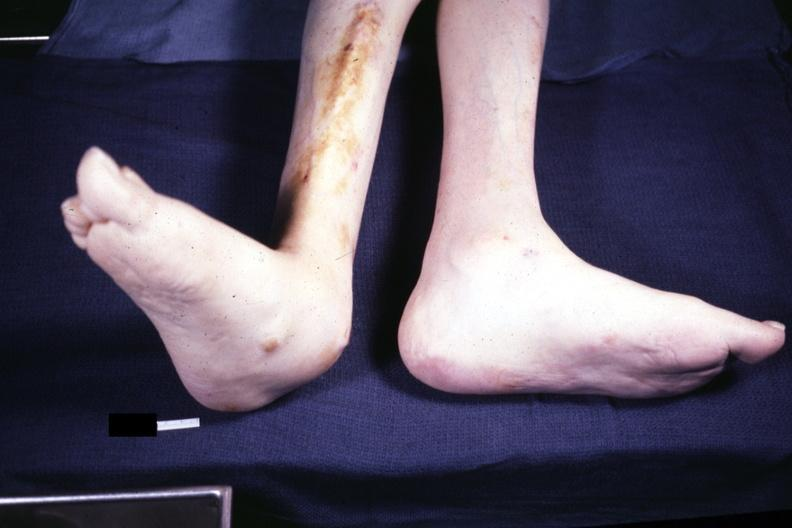what is present?
Answer the question using a single word or phrase. Rheumatoid arthritis 